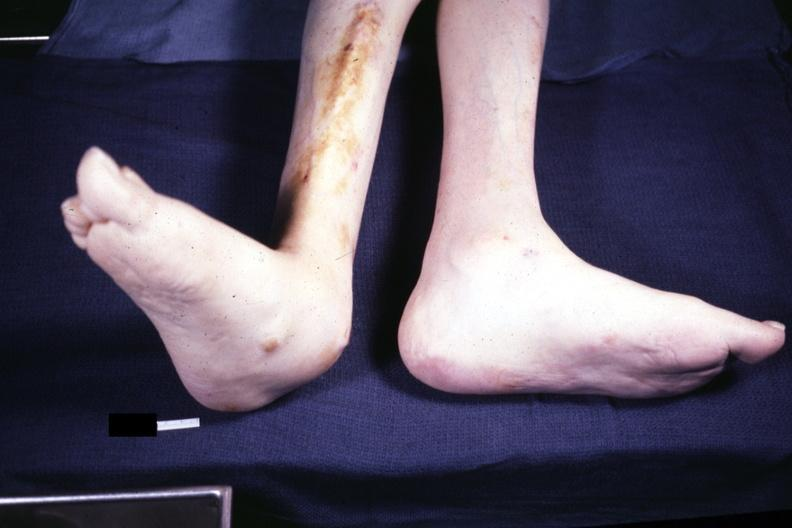what is present?
Answer the question using a single word or phrase. Rheumatoid arthritis 